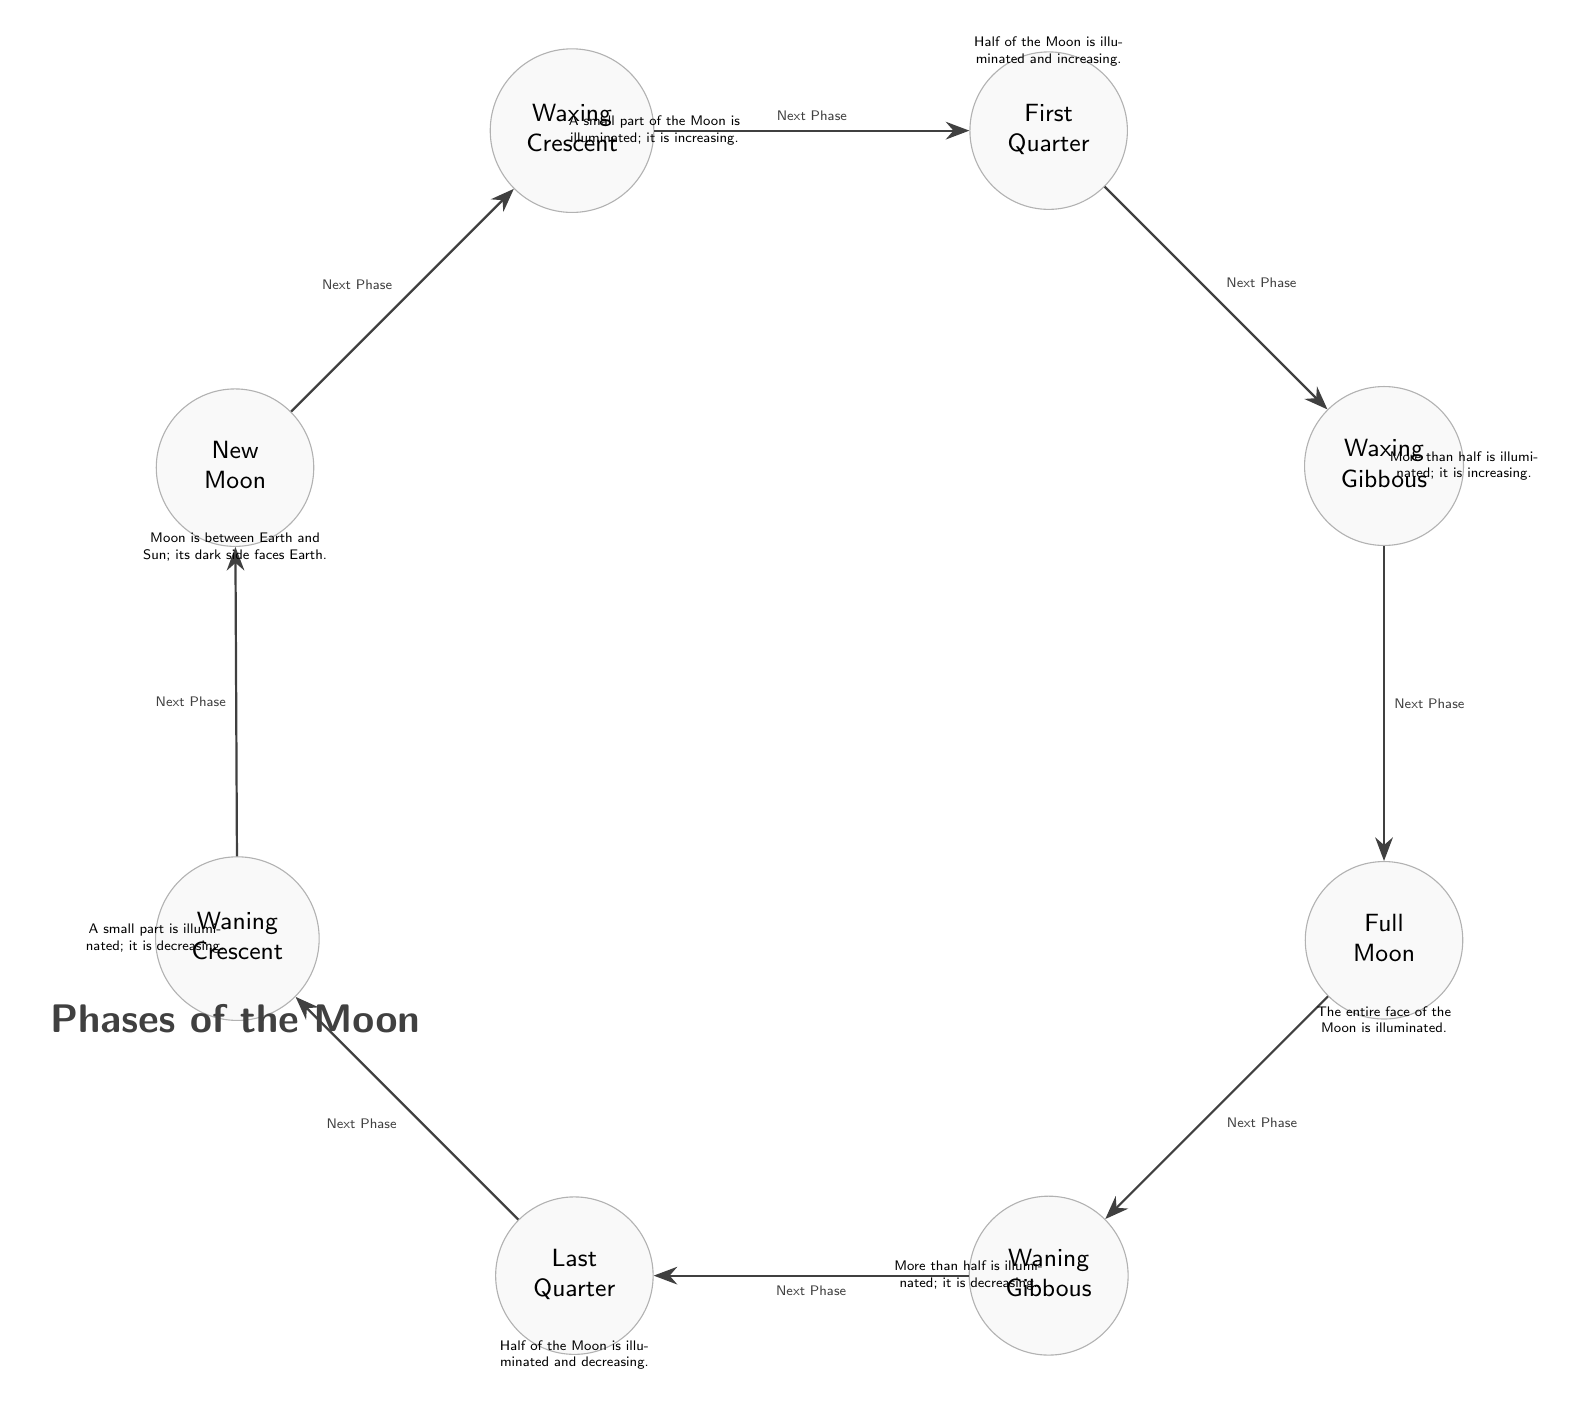What is the first phase of the Moon in the diagram? The first node in the diagram represents the initial phase of the Moon, which is labeled as "New Moon".
Answer: New Moon How many phases are there in total as shown in the diagram? There are eight distinct nodes representing different phases of the Moon.
Answer: Eight What phase follows the Waxing Gibbous? By following the arrows in the diagram from the Waxing Gibbous node, the next phase is indicated as "Full Moon".
Answer: Full Moon What is the illumination status during the Last Quarter phase? The description next to the Last Quarter phase indicates that "Half of the Moon is illuminated and decreasing".
Answer: Half illuminated, decreasing What is the relationship between Waning Crescent and New Moon? The Waning Crescent phase leads back to the New Moon phase, completing the cycle as indicated by the arrow between them.
Answer: Cycle completion What is the phase before the Waxing Crescent? The diagram shows that the phase before Waxing Crescent is "New Moon", as indicated by the arrow pointing towards Waxing Crescent.
Answer: New Moon During which phase is the entire face of the Moon illuminated? According to the information in the diagram, the phase where the entire face of the Moon is illuminated is "Full Moon".
Answer: Full Moon What phase comes after the First Quarter? Following the direction of the arrows in the diagram, the phase that comes after the First Quarter is "Waxing Gibbous".
Answer: Waxing Gibbous What does the diagram indicate about the Moon during a New Moon phase? The description for the New Moon indicates that "Moon is between Earth and Sun; its dark side faces Earth", providing clarity on its position.
Answer: Dark side faces Earth 